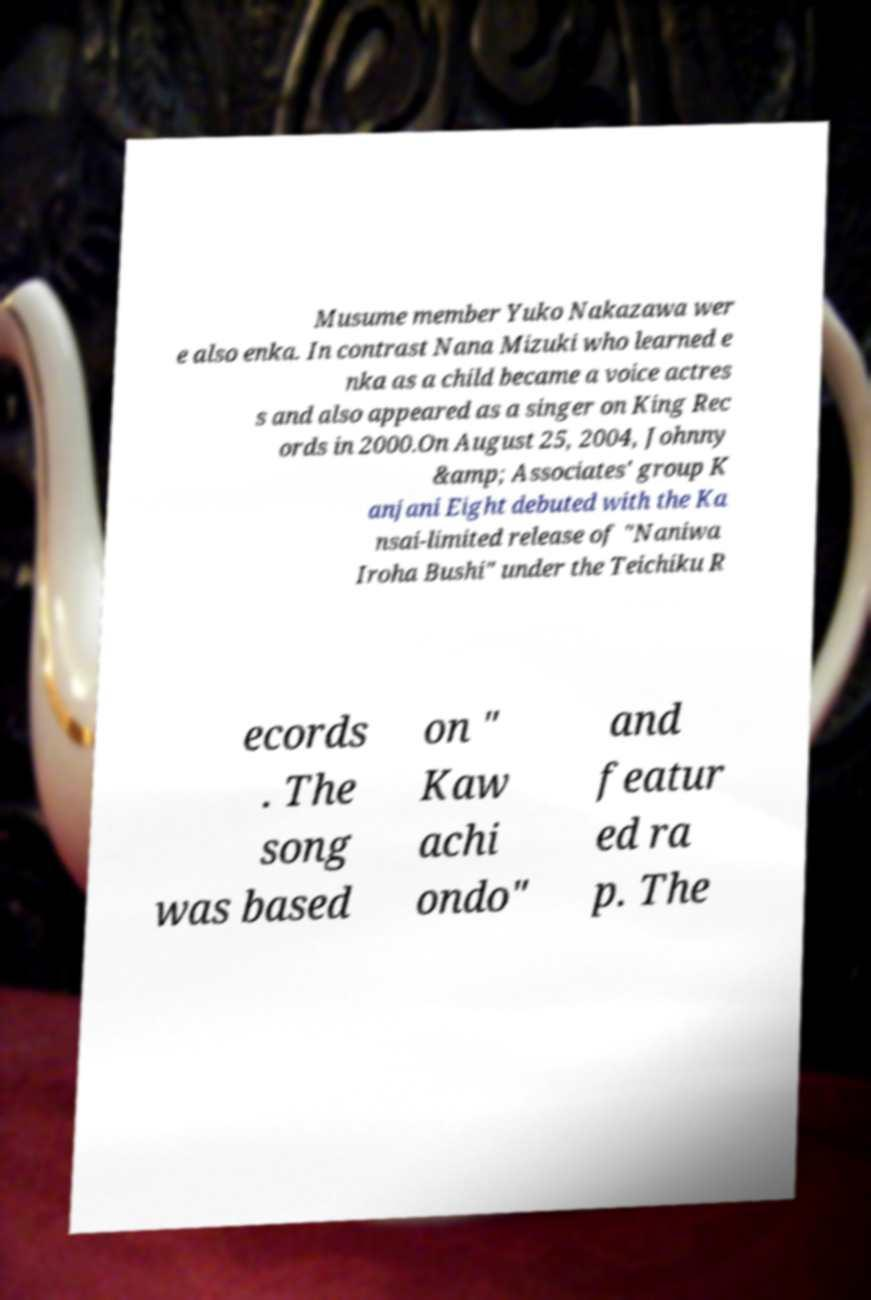Can you read and provide the text displayed in the image?This photo seems to have some interesting text. Can you extract and type it out for me? Musume member Yuko Nakazawa wer e also enka. In contrast Nana Mizuki who learned e nka as a child became a voice actres s and also appeared as a singer on King Rec ords in 2000.On August 25, 2004, Johnny &amp; Associates' group K anjani Eight debuted with the Ka nsai-limited release of "Naniwa Iroha Bushi" under the Teichiku R ecords . The song was based on " Kaw achi ondo" and featur ed ra p. The 